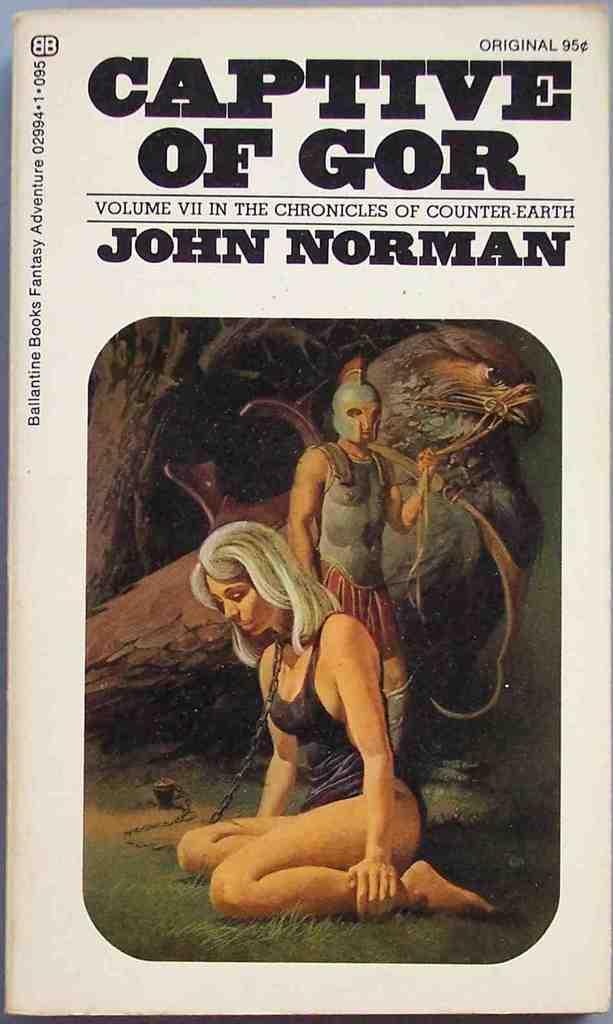Please provide a concise description of this image. In this image we can see a paper with some pictures and text on it. 